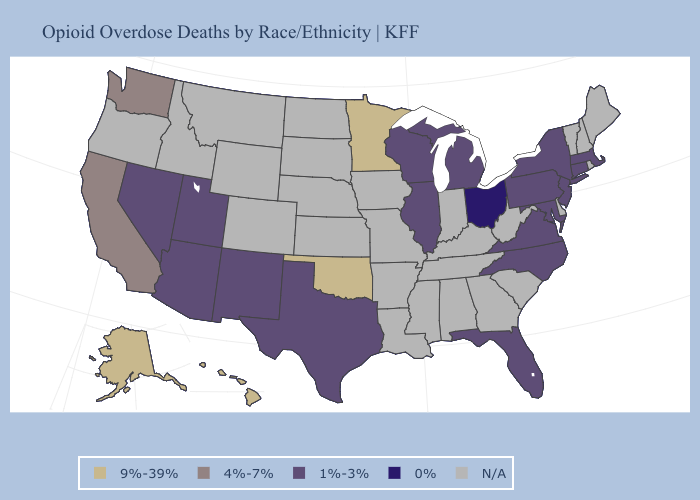What is the highest value in the Northeast ?
Be succinct. 1%-3%. Does the first symbol in the legend represent the smallest category?
Give a very brief answer. No. What is the lowest value in the South?
Write a very short answer. 1%-3%. Does the first symbol in the legend represent the smallest category?
Write a very short answer. No. What is the value of North Dakota?
Keep it brief. N/A. Does Washington have the lowest value in the West?
Answer briefly. No. Name the states that have a value in the range 0%?
Quick response, please. Ohio. Name the states that have a value in the range 4%-7%?
Write a very short answer. California, Washington. Which states hav the highest value in the Northeast?
Concise answer only. Connecticut, Massachusetts, New Jersey, New York, Pennsylvania. Does New Mexico have the lowest value in the USA?
Short answer required. No. Among the states that border Maryland , which have the highest value?
Keep it brief. Pennsylvania, Virginia. What is the value of Montana?
Give a very brief answer. N/A. Does the map have missing data?
Write a very short answer. Yes. 